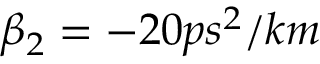<formula> <loc_0><loc_0><loc_500><loc_500>\beta _ { 2 } = - 2 0 p s ^ { 2 } / k m</formula> 